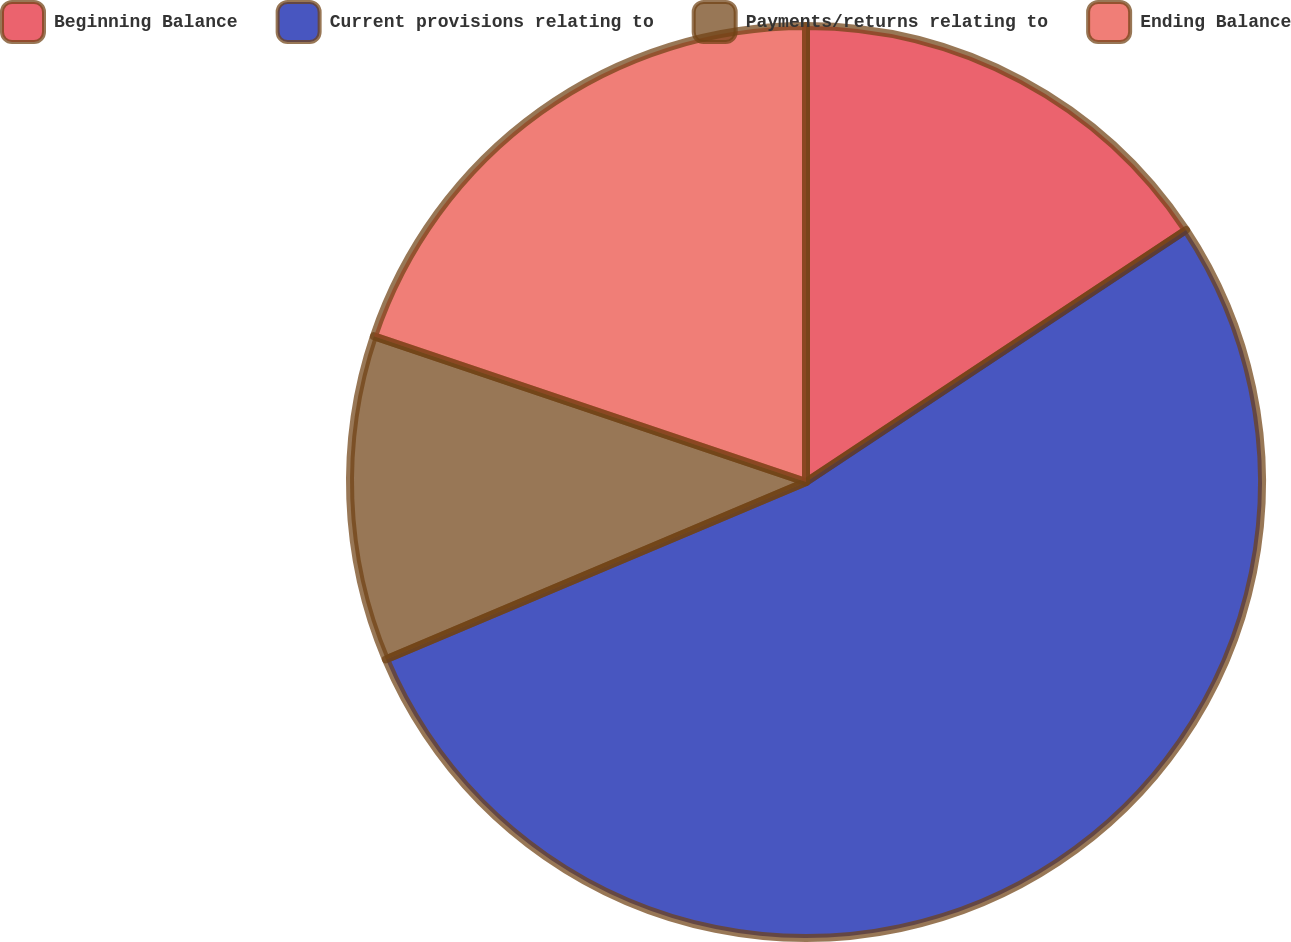Convert chart. <chart><loc_0><loc_0><loc_500><loc_500><pie_chart><fcel>Beginning Balance<fcel>Current provisions relating to<fcel>Payments/returns relating to<fcel>Ending Balance<nl><fcel>15.68%<fcel>52.96%<fcel>11.54%<fcel>19.82%<nl></chart> 